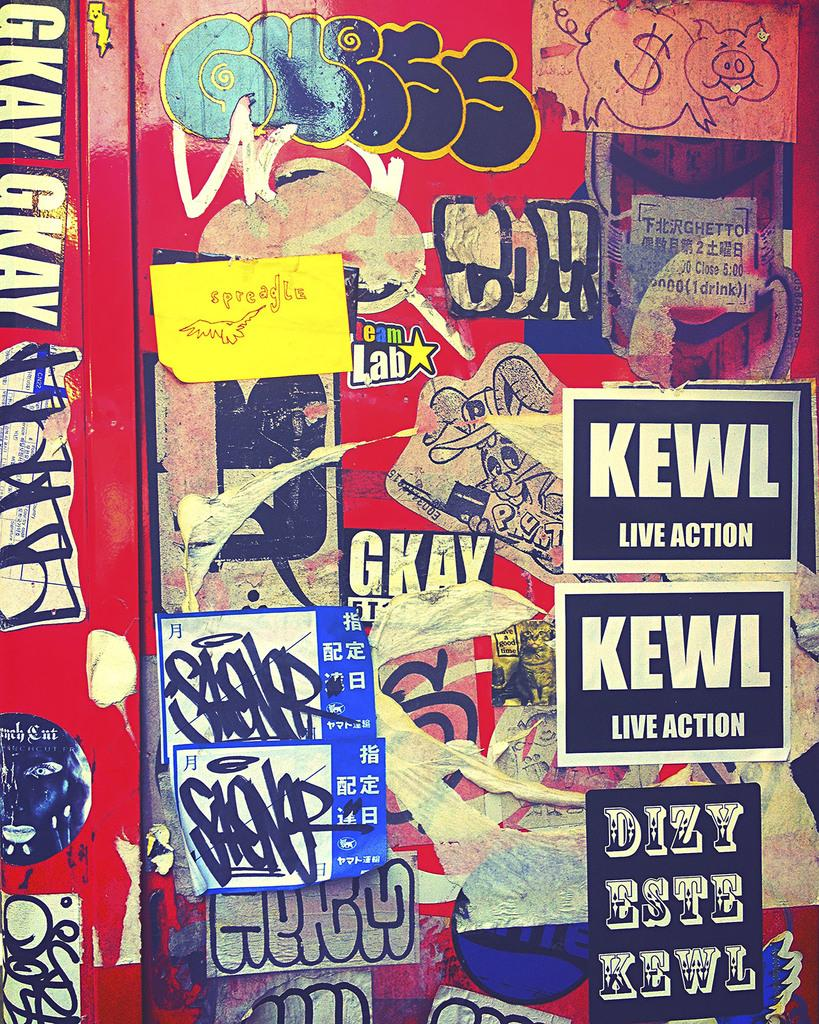<image>
Present a compact description of the photo's key features. Several stickers are pasted on a wall with the words kewl live action printed on them. 